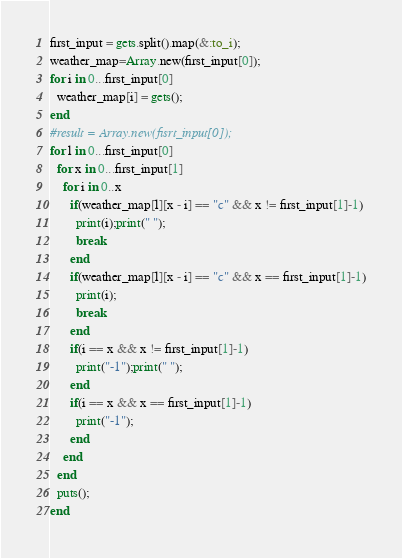Convert code to text. <code><loc_0><loc_0><loc_500><loc_500><_Ruby_>first_input = gets.split().map(&:to_i);
weather_map=Array.new(first_input[0]);
for i in 0...first_input[0]
  weather_map[i] = gets();
end
#result = Array.new(fisrt_input[0]);
for l in 0...first_input[0]
  for x in 0...first_input[1]
    for i in 0..x
      if(weather_map[l][x - i] == "c" && x != first_input[1]-1)
        print(i);print(" ");
        break
      end
      if(weather_map[l][x - i] == "c" && x == first_input[1]-1)
        print(i);
        break
      end
      if(i == x && x != first_input[1]-1)
        print("-1");print(" ");
      end
      if(i == x && x == first_input[1]-1)
        print("-1");
      end
    end
  end
  puts();
end</code> 